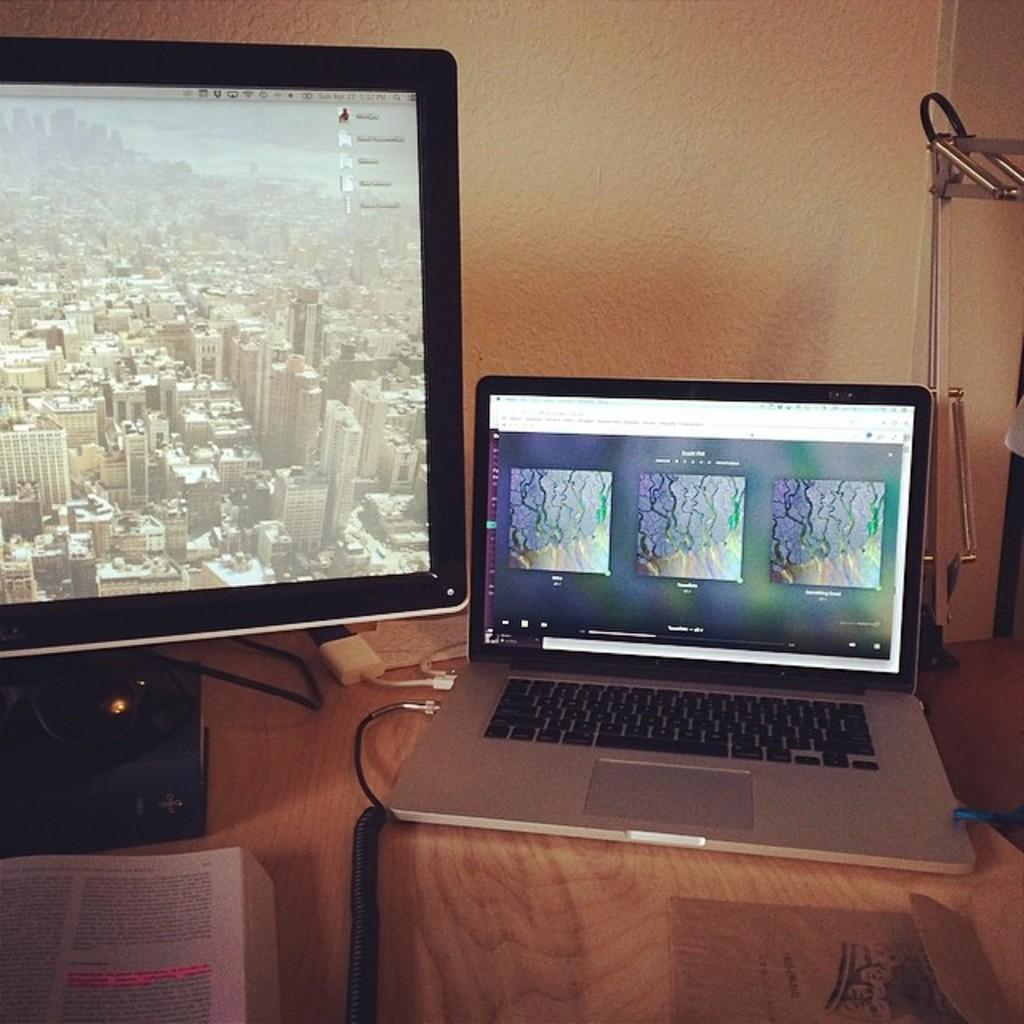How many systems can be seen in the image? There are two systems in the image. What is placed in front of one of the systems? There is a book in front of one of the systems. Can you describe any additional elements in the image? Yes, there is a cable wire in the image. Is there a chair visible in the image? No, there is no chair present in the image. Can you tell me how many kitties are sitting on the book in the image? There are no kitties present in the image. 